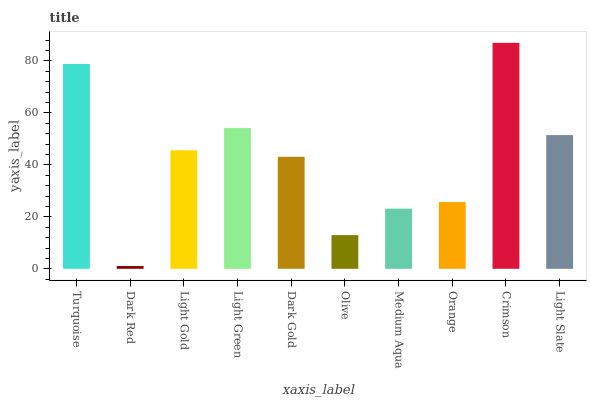Is Light Gold the minimum?
Answer yes or no. No. Is Light Gold the maximum?
Answer yes or no. No. Is Light Gold greater than Dark Red?
Answer yes or no. Yes. Is Dark Red less than Light Gold?
Answer yes or no. Yes. Is Dark Red greater than Light Gold?
Answer yes or no. No. Is Light Gold less than Dark Red?
Answer yes or no. No. Is Light Gold the high median?
Answer yes or no. Yes. Is Dark Gold the low median?
Answer yes or no. Yes. Is Light Slate the high median?
Answer yes or no. No. Is Crimson the low median?
Answer yes or no. No. 